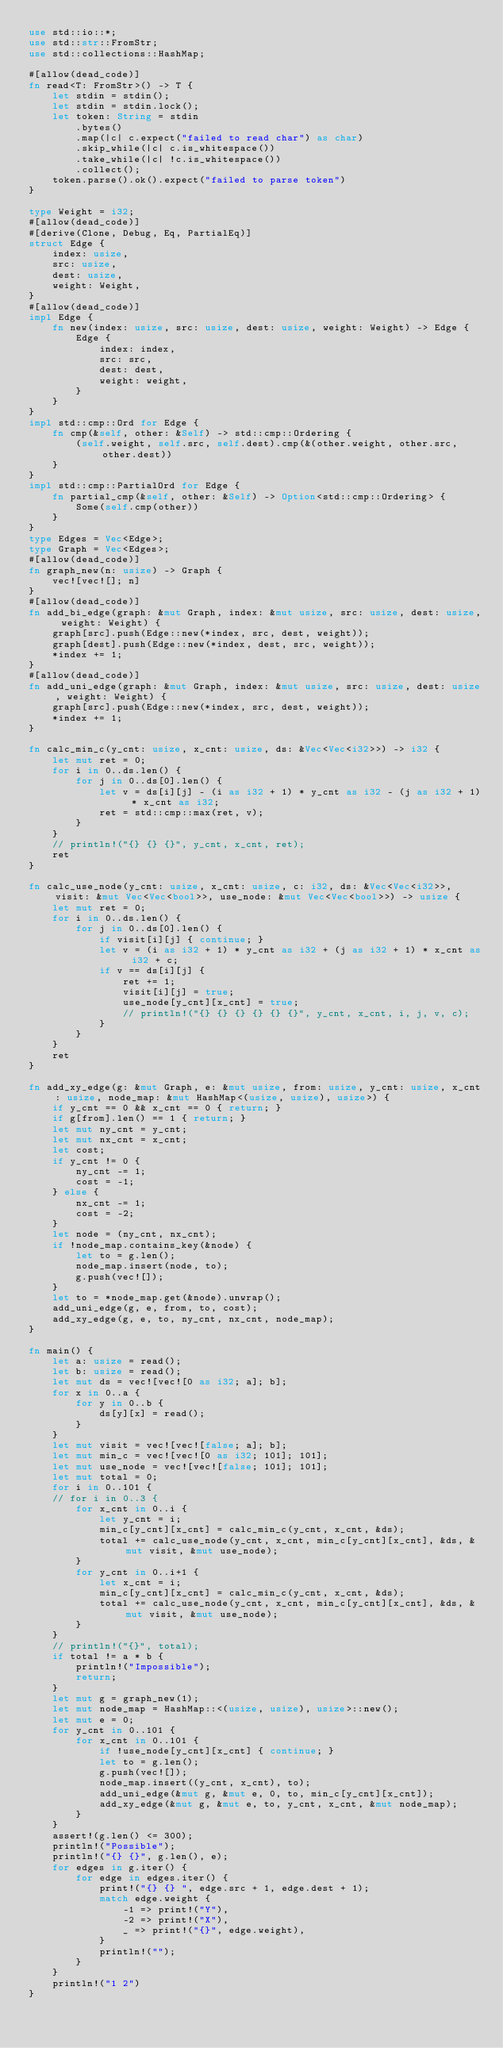<code> <loc_0><loc_0><loc_500><loc_500><_Rust_>use std::io::*;
use std::str::FromStr;
use std::collections::HashMap;

#[allow(dead_code)]
fn read<T: FromStr>() -> T {
    let stdin = stdin();
    let stdin = stdin.lock();
    let token: String = stdin
        .bytes()
        .map(|c| c.expect("failed to read char") as char)
        .skip_while(|c| c.is_whitespace())
        .take_while(|c| !c.is_whitespace())
        .collect();
    token.parse().ok().expect("failed to parse token")
}

type Weight = i32;
#[allow(dead_code)]
#[derive(Clone, Debug, Eq, PartialEq)]
struct Edge {
    index: usize,
    src: usize,
    dest: usize,
    weight: Weight,
}
#[allow(dead_code)]
impl Edge {
    fn new(index: usize, src: usize, dest: usize, weight: Weight) -> Edge {
        Edge {
            index: index,
            src: src,
            dest: dest,
            weight: weight,
        }
    }
}
impl std::cmp::Ord for Edge {
    fn cmp(&self, other: &Self) -> std::cmp::Ordering {
        (self.weight, self.src, self.dest).cmp(&(other.weight, other.src, other.dest))
    }
}
impl std::cmp::PartialOrd for Edge {
    fn partial_cmp(&self, other: &Self) -> Option<std::cmp::Ordering> {
        Some(self.cmp(other))
    }
}
type Edges = Vec<Edge>;
type Graph = Vec<Edges>;
#[allow(dead_code)]
fn graph_new(n: usize) -> Graph {
    vec![vec![]; n]
}
#[allow(dead_code)]
fn add_bi_edge(graph: &mut Graph, index: &mut usize, src: usize, dest: usize, weight: Weight) {
    graph[src].push(Edge::new(*index, src, dest, weight));
    graph[dest].push(Edge::new(*index, dest, src, weight));
    *index += 1;
}
#[allow(dead_code)]
fn add_uni_edge(graph: &mut Graph, index: &mut usize, src: usize, dest: usize, weight: Weight) {
    graph[src].push(Edge::new(*index, src, dest, weight));
    *index += 1;
}

fn calc_min_c(y_cnt: usize, x_cnt: usize, ds: &Vec<Vec<i32>>) -> i32 {
    let mut ret = 0;
    for i in 0..ds.len() {
        for j in 0..ds[0].len() {
            let v = ds[i][j] - (i as i32 + 1) * y_cnt as i32 - (j as i32 + 1) * x_cnt as i32;
            ret = std::cmp::max(ret, v);
        }
    }
    // println!("{} {} {}", y_cnt, x_cnt, ret);
    ret
}

fn calc_use_node(y_cnt: usize, x_cnt: usize, c: i32, ds: &Vec<Vec<i32>>, visit: &mut Vec<Vec<bool>>, use_node: &mut Vec<Vec<bool>>) -> usize {
    let mut ret = 0;
    for i in 0..ds.len() {
        for j in 0..ds[0].len() {
            if visit[i][j] { continue; }
            let v = (i as i32 + 1) * y_cnt as i32 + (j as i32 + 1) * x_cnt as i32 + c;
            if v == ds[i][j] {
                ret += 1;
                visit[i][j] = true;
                use_node[y_cnt][x_cnt] = true;
                // println!("{} {} {} {} {} {}", y_cnt, x_cnt, i, j, v, c);
            }
        }
    }
    ret
}

fn add_xy_edge(g: &mut Graph, e: &mut usize, from: usize, y_cnt: usize, x_cnt: usize, node_map: &mut HashMap<(usize, usize), usize>) {
    if y_cnt == 0 && x_cnt == 0 { return; }
    if g[from].len() == 1 { return; }
    let mut ny_cnt = y_cnt;
    let mut nx_cnt = x_cnt;
    let cost;
    if y_cnt != 0 {
        ny_cnt -= 1;
        cost = -1;
    } else {
        nx_cnt -= 1;
        cost = -2;
    }
    let node = (ny_cnt, nx_cnt);
    if !node_map.contains_key(&node) {
        let to = g.len();
        node_map.insert(node, to);
        g.push(vec![]);
    }
    let to = *node_map.get(&node).unwrap();
    add_uni_edge(g, e, from, to, cost);
    add_xy_edge(g, e, to, ny_cnt, nx_cnt, node_map);
}

fn main() {
    let a: usize = read();
    let b: usize = read();
    let mut ds = vec![vec![0 as i32; a]; b];
    for x in 0..a {
        for y in 0..b {
            ds[y][x] = read();
        }
    }
    let mut visit = vec![vec![false; a]; b];
    let mut min_c = vec![vec![0 as i32; 101]; 101];
    let mut use_node = vec![vec![false; 101]; 101];
    let mut total = 0;
    for i in 0..101 {
    // for i in 0..3 {
        for x_cnt in 0..i {
            let y_cnt = i;
            min_c[y_cnt][x_cnt] = calc_min_c(y_cnt, x_cnt, &ds);
            total += calc_use_node(y_cnt, x_cnt, min_c[y_cnt][x_cnt], &ds, &mut visit, &mut use_node);
        }
        for y_cnt in 0..i+1 {
            let x_cnt = i;
            min_c[y_cnt][x_cnt] = calc_min_c(y_cnt, x_cnt, &ds);
            total += calc_use_node(y_cnt, x_cnt, min_c[y_cnt][x_cnt], &ds, &mut visit, &mut use_node);
        }
    }
    // println!("{}", total);
    if total != a * b {
        println!("Impossible");
        return;
    }
    let mut g = graph_new(1);
    let mut node_map = HashMap::<(usize, usize), usize>::new();
    let mut e = 0;
    for y_cnt in 0..101 {
        for x_cnt in 0..101 {
            if !use_node[y_cnt][x_cnt] { continue; }
            let to = g.len();
            g.push(vec![]);
            node_map.insert((y_cnt, x_cnt), to);
            add_uni_edge(&mut g, &mut e, 0, to, min_c[y_cnt][x_cnt]);
            add_xy_edge(&mut g, &mut e, to, y_cnt, x_cnt, &mut node_map);
        }
    }
    assert!(g.len() <= 300);
    println!("Possible");
    println!("{} {}", g.len(), e);
    for edges in g.iter() {
        for edge in edges.iter() {
            print!("{} {} ", edge.src + 1, edge.dest + 1);
            match edge.weight {
                -1 => print!("Y"),
                -2 => print!("X"),
                _ => print!("{}", edge.weight),
            }
            println!("");
        }
    }
    println!("1 2")
}</code> 